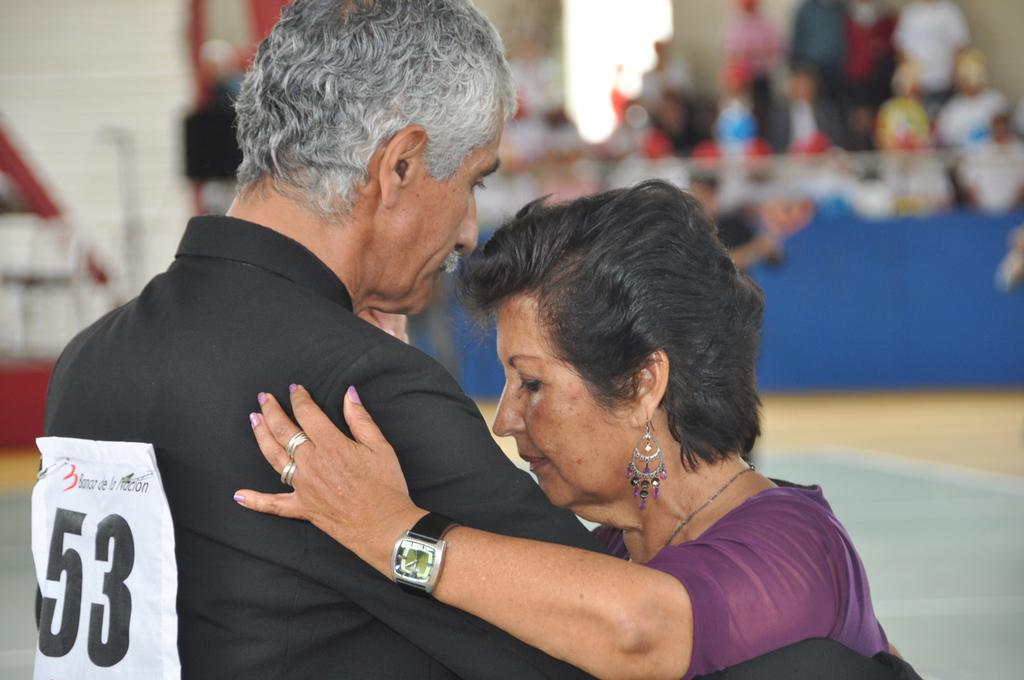<image>
Summarize the visual content of the image. A woman wearing purple dances with a man who has 53 written on his shirt 